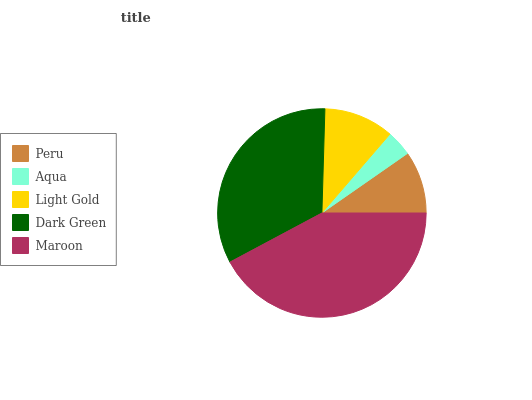Is Aqua the minimum?
Answer yes or no. Yes. Is Maroon the maximum?
Answer yes or no. Yes. Is Light Gold the minimum?
Answer yes or no. No. Is Light Gold the maximum?
Answer yes or no. No. Is Light Gold greater than Aqua?
Answer yes or no. Yes. Is Aqua less than Light Gold?
Answer yes or no. Yes. Is Aqua greater than Light Gold?
Answer yes or no. No. Is Light Gold less than Aqua?
Answer yes or no. No. Is Light Gold the high median?
Answer yes or no. Yes. Is Light Gold the low median?
Answer yes or no. Yes. Is Maroon the high median?
Answer yes or no. No. Is Aqua the low median?
Answer yes or no. No. 